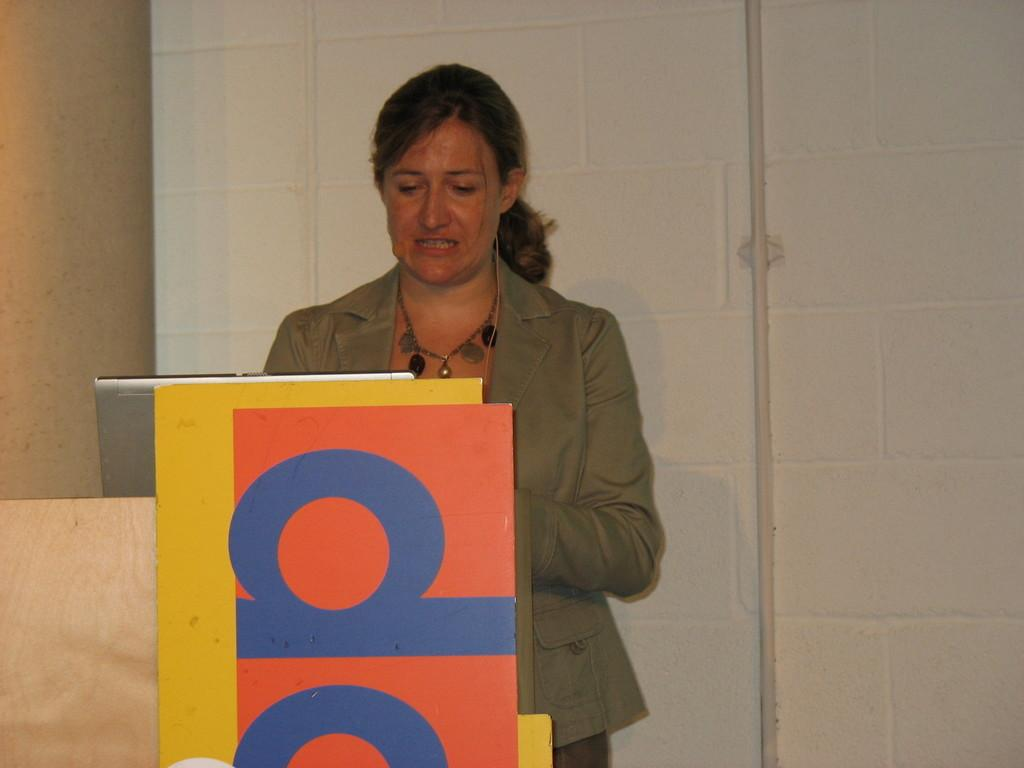What is the main subject of the image? There is a person standing in the image. What is the person wearing? The person is wearing a cream-colored blazer. What electronic device is visible in the image? There is a laptop visible in the image. What color is the wall in the background? The wall in the background is white. How many brothers does the person in the image have? There is no information about the person's brothers in the image. What verse is being recited by the person in the image? There is no indication that the person is reciting a verse in the image. 